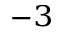Convert formula to latex. <formula><loc_0><loc_0><loc_500><loc_500>^ { - 3 }</formula> 